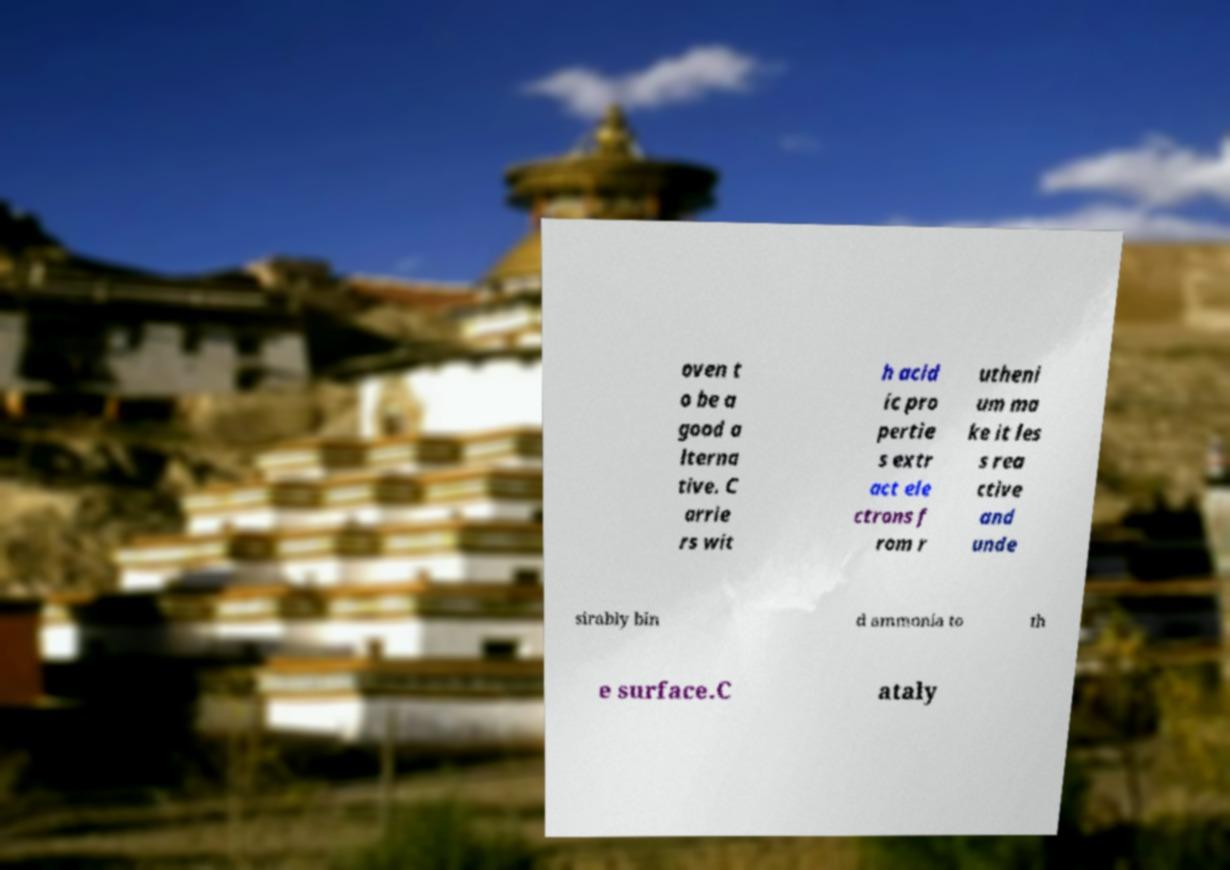Can you read and provide the text displayed in the image?This photo seems to have some interesting text. Can you extract and type it out for me? oven t o be a good a lterna tive. C arrie rs wit h acid ic pro pertie s extr act ele ctrons f rom r utheni um ma ke it les s rea ctive and unde sirably bin d ammonia to th e surface.C ataly 